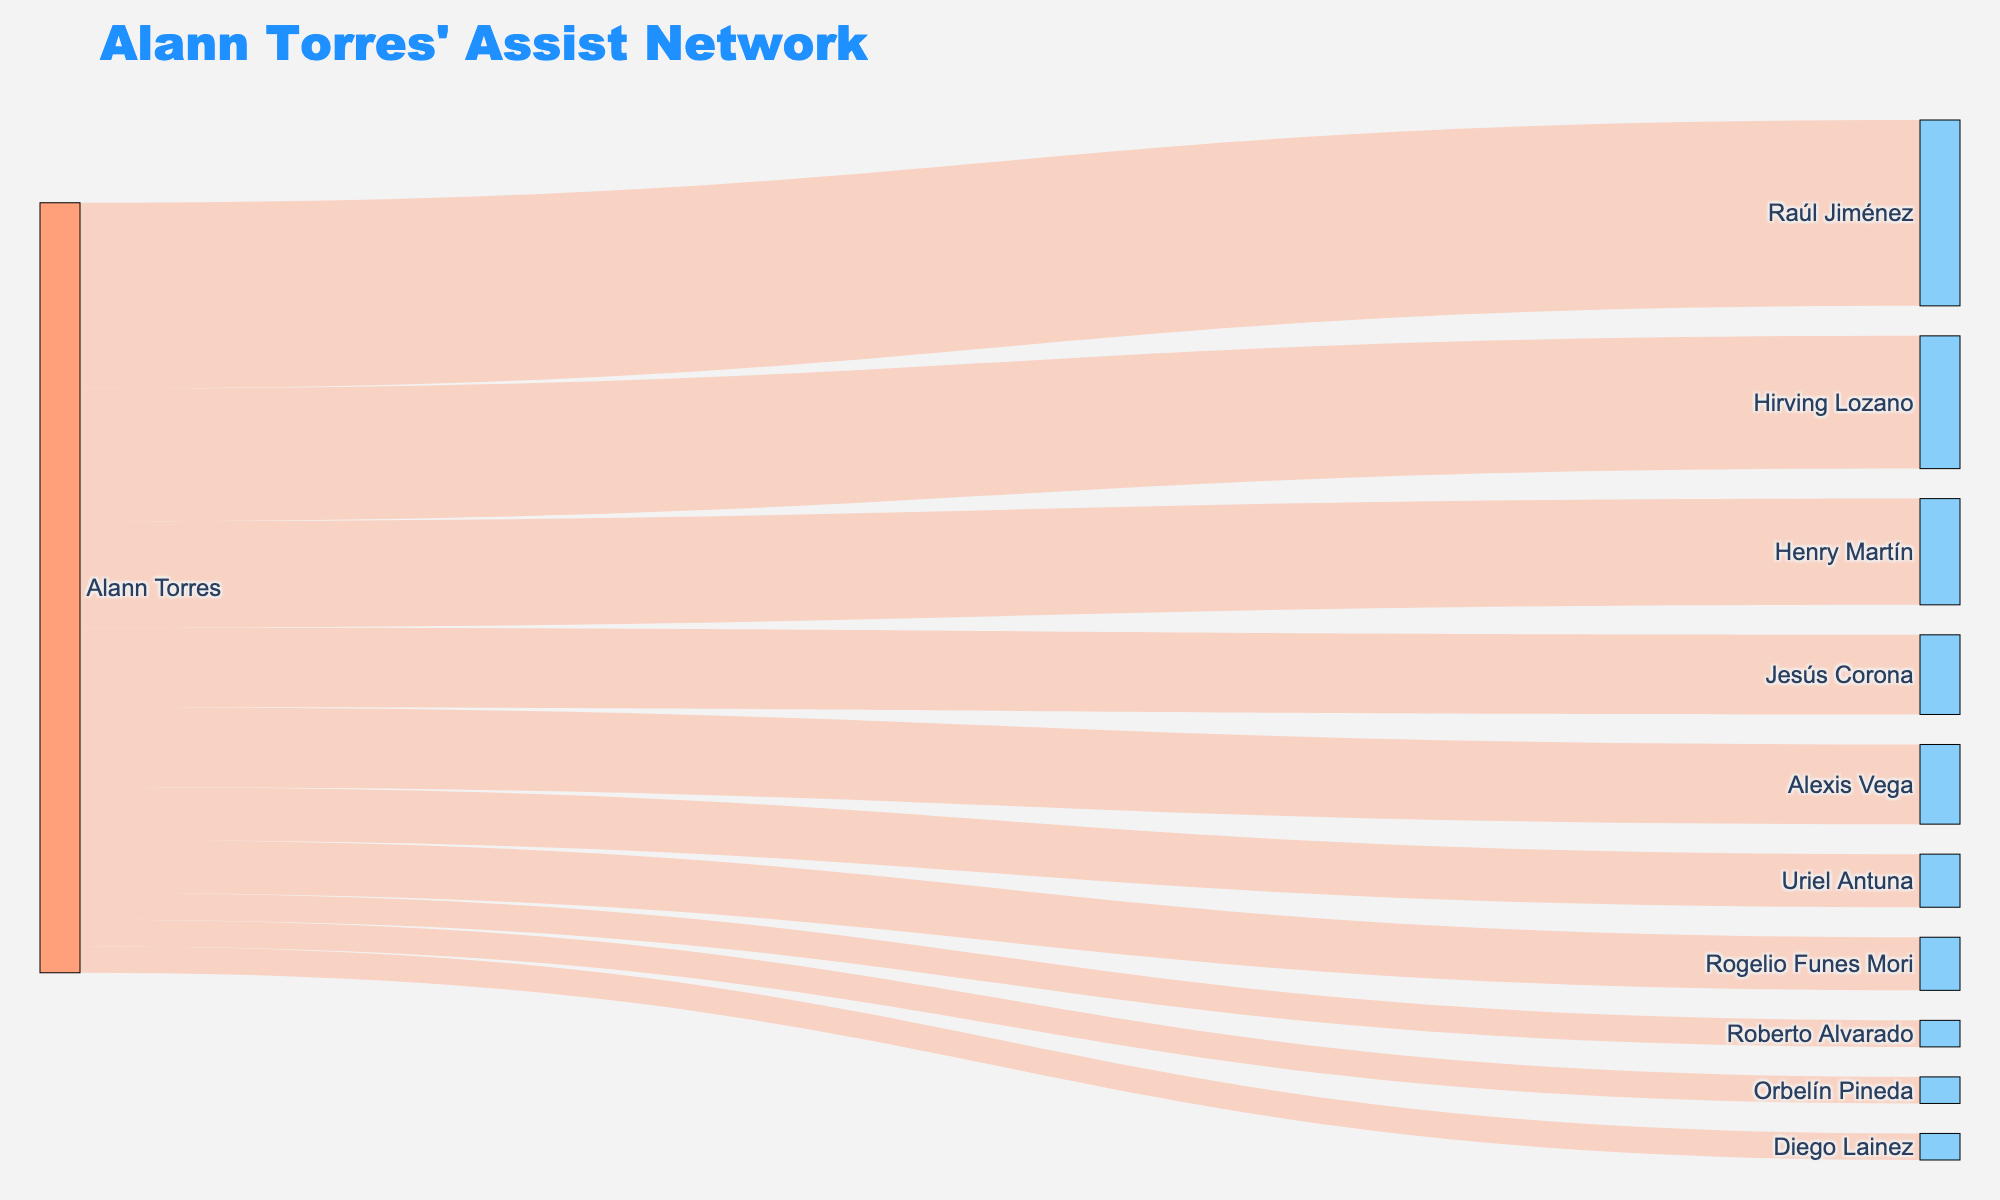Which player has received the most assists from Alann Torres? Alann Torres has assisted Raúl Jiménez the most. This is indicated by the highest value of 7 in the connection between Alann Torres and Raúl Jiménez in the Sankey diagram.
Answer: Raúl Jiménez How many players have received exactly 2 assists from Alann Torres? By counting the connections with the value of 2, we find that Uriel Antuna and Rogelio Funes Mori each received exactly 2 assists. That's a total of 2 players.
Answer: 2 What is the total number of assists made by Alann Torres, as shown in the diagram? Summing the values of all connections: 7 (Jiménez) + 5 (Lozano) + 4 (Martín) + 3 (Corona) + 3 (Vega) + 2 (Antuna) + 2 (Funes Mori) + 1 (Lainez) + 1 (Pineda) + 1 (Alvarado) = 29.
Answer: 29 Which player has received fewer assists from Alann Torres: Jesús Corona or Henry Martín? Jesús Corona has received 3 assists, while Henry Martín has received 4 assists from Alann Torres. Therefore, Jesús Corona has received fewer assists.
Answer: Jesús Corona Who is the least assisted player in the diagram? The players with the least assists (value of 1) are Diego Lainez, Orbelín Pineda, and Roberto Alvarado.
Answer: Diego Lainez, Orbelín Pineda, Roberto Alvarado Which players have received more than 3 assists from Alann Torres? By inspecting the connections with values greater than 3: Raúl Jiménez (7), Hirving Lozano (5), and Henry Martín (4) meet the criteria.
Answer: Raúl Jiménez, Hirving Lozano, Henry Martín What is the average number of assists Alann Torres has given to the players shown in the diagram? The total number of assists is 29. There are 10 players. So, the average is 29 ÷ 10 = 2.9.
Answer: 2.9 What is the combined total of assists given to Hirving Lozano and Alexis Vega by Alann Torres? Hirving Lozano has received 5 assists, and Alexis Vega has received 3 assists. Their combined total is 5 + 3 = 8.
Answer: 8 Compare the number of assists between the top two assisted players. How many more assists does the top player have? Raúl Jiménez has 7 assists, and Hirving Lozano has 5 assists. The difference is 7 - 5 = 2 assists.
Answer: 2 